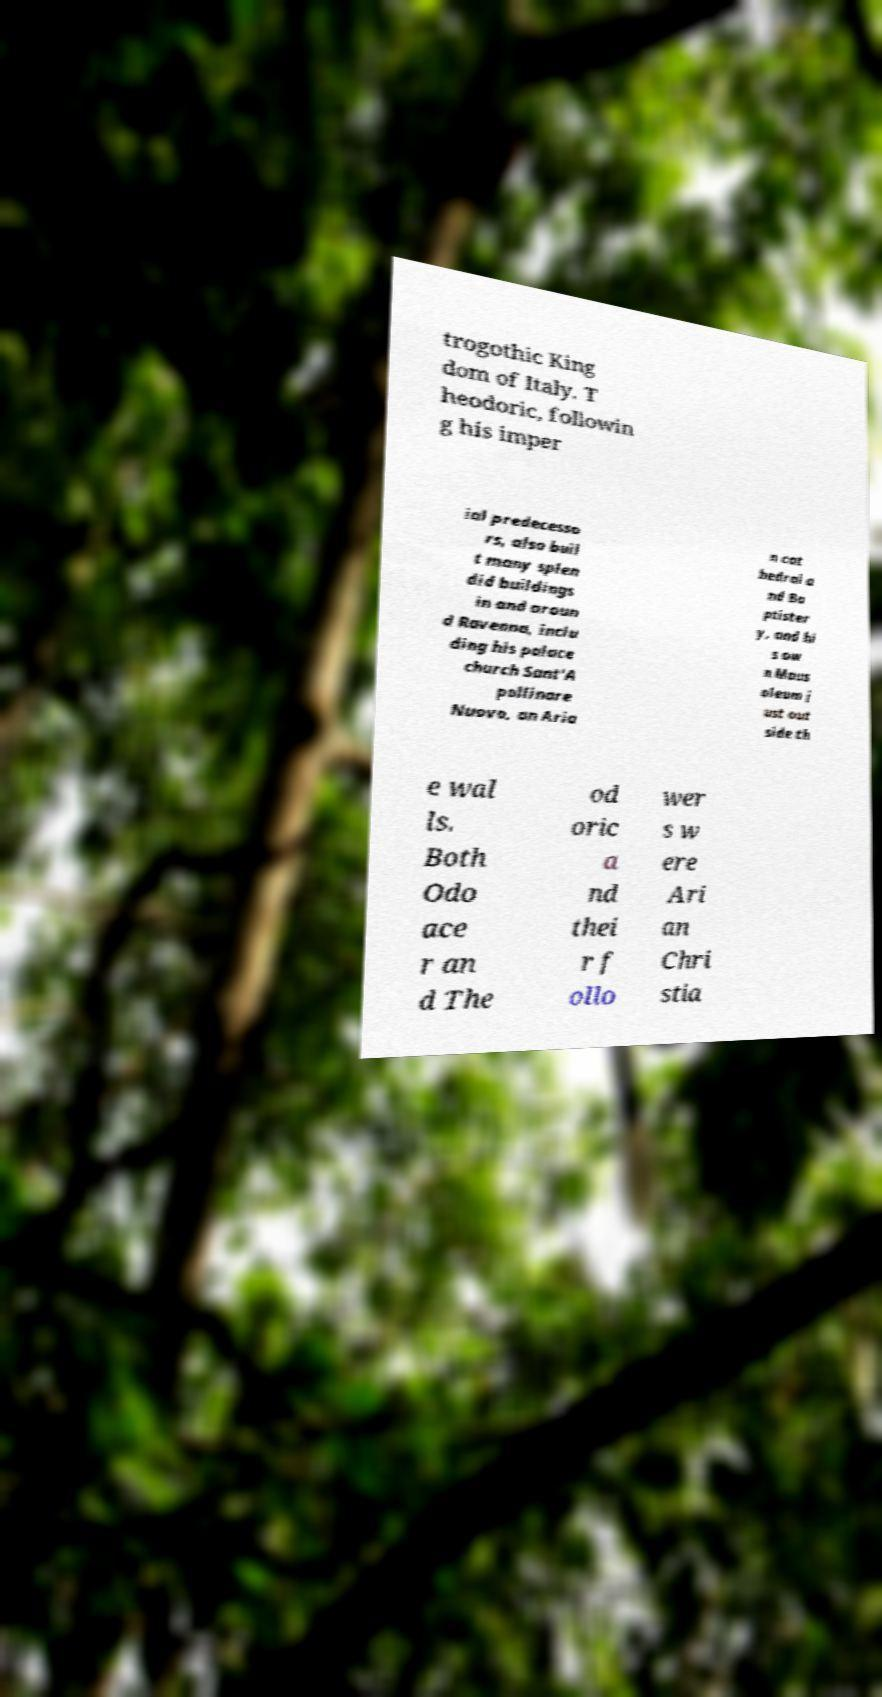For documentation purposes, I need the text within this image transcribed. Could you provide that? trogothic King dom of Italy. T heodoric, followin g his imper ial predecesso rs, also buil t many splen did buildings in and aroun d Ravenna, inclu ding his palace church Sant'A pollinare Nuovo, an Aria n cat hedral a nd Ba ptister y, and hi s ow n Maus oleum j ust out side th e wal ls. Both Odo ace r an d The od oric a nd thei r f ollo wer s w ere Ari an Chri stia 